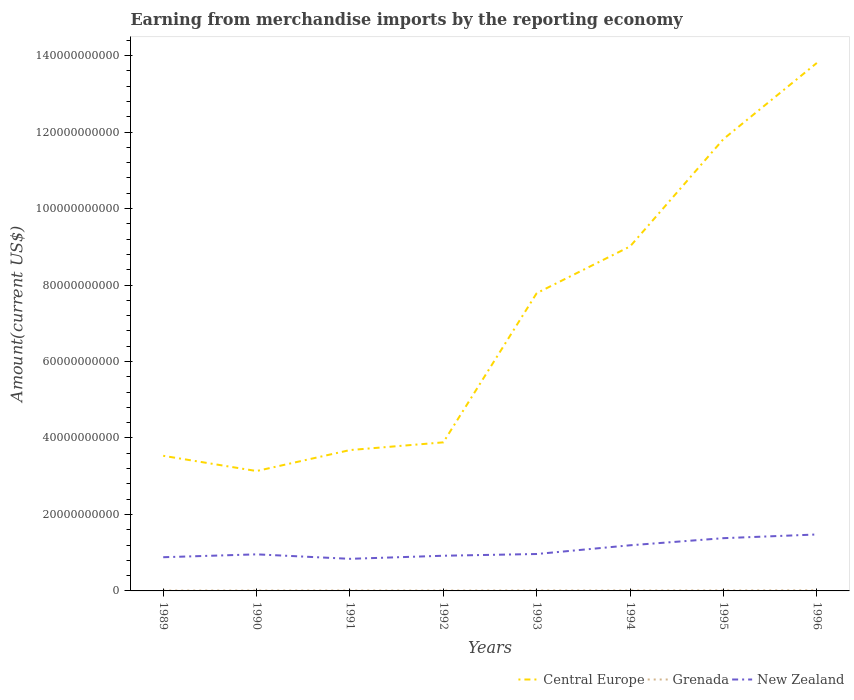Is the number of lines equal to the number of legend labels?
Keep it short and to the point. Yes. Across all years, what is the maximum amount earned from merchandise imports in New Zealand?
Give a very brief answer. 8.39e+09. What is the total amount earned from merchandise imports in New Zealand in the graph?
Keep it short and to the point. -5.95e+09. What is the difference between the highest and the second highest amount earned from merchandise imports in Grenada?
Ensure brevity in your answer.  5.36e+07. What is the difference between the highest and the lowest amount earned from merchandise imports in Grenada?
Your answer should be very brief. 3. How many years are there in the graph?
Offer a very short reply. 8. Are the values on the major ticks of Y-axis written in scientific E-notation?
Your answer should be very brief. No. Where does the legend appear in the graph?
Your answer should be compact. Bottom right. How are the legend labels stacked?
Your answer should be very brief. Horizontal. What is the title of the graph?
Give a very brief answer. Earning from merchandise imports by the reporting economy. What is the label or title of the Y-axis?
Provide a succinct answer. Amount(current US$). What is the Amount(current US$) of Central Europe in 1989?
Offer a very short reply. 3.53e+1. What is the Amount(current US$) in Grenada in 1989?
Provide a short and direct response. 1.01e+08. What is the Amount(current US$) of New Zealand in 1989?
Your answer should be compact. 8.81e+09. What is the Amount(current US$) in Central Europe in 1990?
Give a very brief answer. 3.14e+1. What is the Amount(current US$) in Grenada in 1990?
Provide a short and direct response. 1.09e+08. What is the Amount(current US$) of New Zealand in 1990?
Make the answer very short. 9.57e+09. What is the Amount(current US$) in Central Europe in 1991?
Make the answer very short. 3.68e+1. What is the Amount(current US$) of Grenada in 1991?
Your answer should be compact. 1.17e+08. What is the Amount(current US$) of New Zealand in 1991?
Provide a succinct answer. 8.39e+09. What is the Amount(current US$) of Central Europe in 1992?
Offer a terse response. 3.89e+1. What is the Amount(current US$) of Grenada in 1992?
Keep it short and to the point. 1.02e+08. What is the Amount(current US$) of New Zealand in 1992?
Make the answer very short. 9.20e+09. What is the Amount(current US$) in Central Europe in 1993?
Your response must be concise. 7.79e+1. What is the Amount(current US$) of Grenada in 1993?
Provide a succinct answer. 1.27e+08. What is the Amount(current US$) in New Zealand in 1993?
Provide a succinct answer. 9.66e+09. What is the Amount(current US$) of Central Europe in 1994?
Your answer should be very brief. 9.01e+1. What is the Amount(current US$) in Grenada in 1994?
Your response must be concise. 1.20e+08. What is the Amount(current US$) in New Zealand in 1994?
Your answer should be compact. 1.19e+1. What is the Amount(current US$) of Central Europe in 1995?
Provide a short and direct response. 1.18e+11. What is the Amount(current US$) in Grenada in 1995?
Ensure brevity in your answer.  1.30e+08. What is the Amount(current US$) of New Zealand in 1995?
Make the answer very short. 1.38e+1. What is the Amount(current US$) of Central Europe in 1996?
Your answer should be very brief. 1.38e+11. What is the Amount(current US$) in Grenada in 1996?
Offer a very short reply. 1.54e+08. What is the Amount(current US$) of New Zealand in 1996?
Your answer should be very brief. 1.48e+1. Across all years, what is the maximum Amount(current US$) in Central Europe?
Provide a short and direct response. 1.38e+11. Across all years, what is the maximum Amount(current US$) in Grenada?
Your response must be concise. 1.54e+08. Across all years, what is the maximum Amount(current US$) of New Zealand?
Ensure brevity in your answer.  1.48e+1. Across all years, what is the minimum Amount(current US$) in Central Europe?
Make the answer very short. 3.14e+1. Across all years, what is the minimum Amount(current US$) in Grenada?
Keep it short and to the point. 1.01e+08. Across all years, what is the minimum Amount(current US$) in New Zealand?
Ensure brevity in your answer.  8.39e+09. What is the total Amount(current US$) in Central Europe in the graph?
Keep it short and to the point. 5.67e+11. What is the total Amount(current US$) in Grenada in the graph?
Provide a succinct answer. 9.60e+08. What is the total Amount(current US$) of New Zealand in the graph?
Your answer should be compact. 8.61e+1. What is the difference between the Amount(current US$) of Central Europe in 1989 and that in 1990?
Ensure brevity in your answer.  3.99e+09. What is the difference between the Amount(current US$) of Grenada in 1989 and that in 1990?
Provide a short and direct response. -8.09e+06. What is the difference between the Amount(current US$) in New Zealand in 1989 and that in 1990?
Provide a short and direct response. -7.53e+08. What is the difference between the Amount(current US$) in Central Europe in 1989 and that in 1991?
Keep it short and to the point. -1.50e+09. What is the difference between the Amount(current US$) of Grenada in 1989 and that in 1991?
Your response must be concise. -1.64e+07. What is the difference between the Amount(current US$) of New Zealand in 1989 and that in 1991?
Make the answer very short. 4.20e+08. What is the difference between the Amount(current US$) in Central Europe in 1989 and that in 1992?
Make the answer very short. -3.52e+09. What is the difference between the Amount(current US$) of Grenada in 1989 and that in 1992?
Keep it short and to the point. -1.53e+06. What is the difference between the Amount(current US$) of New Zealand in 1989 and that in 1992?
Make the answer very short. -3.88e+08. What is the difference between the Amount(current US$) of Central Europe in 1989 and that in 1993?
Give a very brief answer. -4.25e+1. What is the difference between the Amount(current US$) in Grenada in 1989 and that in 1993?
Ensure brevity in your answer.  -2.57e+07. What is the difference between the Amount(current US$) of New Zealand in 1989 and that in 1993?
Give a very brief answer. -8.44e+08. What is the difference between the Amount(current US$) of Central Europe in 1989 and that in 1994?
Keep it short and to the point. -5.48e+1. What is the difference between the Amount(current US$) in Grenada in 1989 and that in 1994?
Your answer should be compact. -1.88e+07. What is the difference between the Amount(current US$) in New Zealand in 1989 and that in 1994?
Ensure brevity in your answer.  -3.12e+09. What is the difference between the Amount(current US$) of Central Europe in 1989 and that in 1995?
Provide a short and direct response. -8.28e+1. What is the difference between the Amount(current US$) of Grenada in 1989 and that in 1995?
Give a very brief answer. -2.92e+07. What is the difference between the Amount(current US$) in New Zealand in 1989 and that in 1995?
Keep it short and to the point. -4.98e+09. What is the difference between the Amount(current US$) in Central Europe in 1989 and that in 1996?
Ensure brevity in your answer.  -1.03e+11. What is the difference between the Amount(current US$) in Grenada in 1989 and that in 1996?
Your answer should be very brief. -5.36e+07. What is the difference between the Amount(current US$) in New Zealand in 1989 and that in 1996?
Your response must be concise. -5.95e+09. What is the difference between the Amount(current US$) in Central Europe in 1990 and that in 1991?
Ensure brevity in your answer.  -5.49e+09. What is the difference between the Amount(current US$) of Grenada in 1990 and that in 1991?
Ensure brevity in your answer.  -8.32e+06. What is the difference between the Amount(current US$) of New Zealand in 1990 and that in 1991?
Provide a succinct answer. 1.17e+09. What is the difference between the Amount(current US$) in Central Europe in 1990 and that in 1992?
Ensure brevity in your answer.  -7.50e+09. What is the difference between the Amount(current US$) of Grenada in 1990 and that in 1992?
Offer a very short reply. 6.56e+06. What is the difference between the Amount(current US$) of New Zealand in 1990 and that in 1992?
Your answer should be very brief. 3.65e+08. What is the difference between the Amount(current US$) in Central Europe in 1990 and that in 1993?
Your response must be concise. -4.65e+1. What is the difference between the Amount(current US$) in Grenada in 1990 and that in 1993?
Offer a terse response. -1.76e+07. What is the difference between the Amount(current US$) of New Zealand in 1990 and that in 1993?
Provide a succinct answer. -9.07e+07. What is the difference between the Amount(current US$) of Central Europe in 1990 and that in 1994?
Your answer should be compact. -5.87e+1. What is the difference between the Amount(current US$) of Grenada in 1990 and that in 1994?
Your answer should be very brief. -1.07e+07. What is the difference between the Amount(current US$) in New Zealand in 1990 and that in 1994?
Ensure brevity in your answer.  -2.37e+09. What is the difference between the Amount(current US$) in Central Europe in 1990 and that in 1995?
Keep it short and to the point. -8.68e+1. What is the difference between the Amount(current US$) of Grenada in 1990 and that in 1995?
Offer a very short reply. -2.11e+07. What is the difference between the Amount(current US$) in New Zealand in 1990 and that in 1995?
Ensure brevity in your answer.  -4.23e+09. What is the difference between the Amount(current US$) of Central Europe in 1990 and that in 1996?
Make the answer very short. -1.07e+11. What is the difference between the Amount(current US$) of Grenada in 1990 and that in 1996?
Make the answer very short. -4.55e+07. What is the difference between the Amount(current US$) in New Zealand in 1990 and that in 1996?
Your answer should be compact. -5.20e+09. What is the difference between the Amount(current US$) in Central Europe in 1991 and that in 1992?
Provide a succinct answer. -2.02e+09. What is the difference between the Amount(current US$) in Grenada in 1991 and that in 1992?
Provide a short and direct response. 1.49e+07. What is the difference between the Amount(current US$) of New Zealand in 1991 and that in 1992?
Offer a very short reply. -8.08e+08. What is the difference between the Amount(current US$) in Central Europe in 1991 and that in 1993?
Your response must be concise. -4.10e+1. What is the difference between the Amount(current US$) in Grenada in 1991 and that in 1993?
Ensure brevity in your answer.  -9.29e+06. What is the difference between the Amount(current US$) of New Zealand in 1991 and that in 1993?
Your answer should be compact. -1.26e+09. What is the difference between the Amount(current US$) in Central Europe in 1991 and that in 1994?
Your answer should be compact. -5.33e+1. What is the difference between the Amount(current US$) of Grenada in 1991 and that in 1994?
Keep it short and to the point. -2.39e+06. What is the difference between the Amount(current US$) of New Zealand in 1991 and that in 1994?
Offer a terse response. -3.54e+09. What is the difference between the Amount(current US$) of Central Europe in 1991 and that in 1995?
Your answer should be very brief. -8.13e+1. What is the difference between the Amount(current US$) in Grenada in 1991 and that in 1995?
Provide a short and direct response. -1.28e+07. What is the difference between the Amount(current US$) in New Zealand in 1991 and that in 1995?
Offer a terse response. -5.40e+09. What is the difference between the Amount(current US$) of Central Europe in 1991 and that in 1996?
Provide a short and direct response. -1.01e+11. What is the difference between the Amount(current US$) of Grenada in 1991 and that in 1996?
Offer a terse response. -3.72e+07. What is the difference between the Amount(current US$) of New Zealand in 1991 and that in 1996?
Provide a succinct answer. -6.37e+09. What is the difference between the Amount(current US$) in Central Europe in 1992 and that in 1993?
Provide a succinct answer. -3.90e+1. What is the difference between the Amount(current US$) of Grenada in 1992 and that in 1993?
Offer a terse response. -2.42e+07. What is the difference between the Amount(current US$) of New Zealand in 1992 and that in 1993?
Keep it short and to the point. -4.56e+08. What is the difference between the Amount(current US$) of Central Europe in 1992 and that in 1994?
Your response must be concise. -5.12e+1. What is the difference between the Amount(current US$) in Grenada in 1992 and that in 1994?
Provide a succinct answer. -1.73e+07. What is the difference between the Amount(current US$) in New Zealand in 1992 and that in 1994?
Your response must be concise. -2.73e+09. What is the difference between the Amount(current US$) in Central Europe in 1992 and that in 1995?
Provide a short and direct response. -7.93e+1. What is the difference between the Amount(current US$) of Grenada in 1992 and that in 1995?
Offer a very short reply. -2.77e+07. What is the difference between the Amount(current US$) in New Zealand in 1992 and that in 1995?
Offer a very short reply. -4.59e+09. What is the difference between the Amount(current US$) of Central Europe in 1992 and that in 1996?
Your answer should be compact. -9.92e+1. What is the difference between the Amount(current US$) of Grenada in 1992 and that in 1996?
Your response must be concise. -5.20e+07. What is the difference between the Amount(current US$) of New Zealand in 1992 and that in 1996?
Give a very brief answer. -5.56e+09. What is the difference between the Amount(current US$) in Central Europe in 1993 and that in 1994?
Keep it short and to the point. -1.22e+1. What is the difference between the Amount(current US$) of Grenada in 1993 and that in 1994?
Offer a very short reply. 6.89e+06. What is the difference between the Amount(current US$) in New Zealand in 1993 and that in 1994?
Your answer should be very brief. -2.28e+09. What is the difference between the Amount(current US$) of Central Europe in 1993 and that in 1995?
Your answer should be very brief. -4.03e+1. What is the difference between the Amount(current US$) of Grenada in 1993 and that in 1995?
Your response must be concise. -3.49e+06. What is the difference between the Amount(current US$) in New Zealand in 1993 and that in 1995?
Make the answer very short. -4.14e+09. What is the difference between the Amount(current US$) of Central Europe in 1993 and that in 1996?
Offer a very short reply. -6.02e+1. What is the difference between the Amount(current US$) in Grenada in 1993 and that in 1996?
Offer a very short reply. -2.79e+07. What is the difference between the Amount(current US$) in New Zealand in 1993 and that in 1996?
Provide a short and direct response. -5.11e+09. What is the difference between the Amount(current US$) of Central Europe in 1994 and that in 1995?
Your response must be concise. -2.81e+1. What is the difference between the Amount(current US$) of Grenada in 1994 and that in 1995?
Provide a short and direct response. -1.04e+07. What is the difference between the Amount(current US$) in New Zealand in 1994 and that in 1995?
Keep it short and to the point. -1.86e+09. What is the difference between the Amount(current US$) in Central Europe in 1994 and that in 1996?
Provide a short and direct response. -4.80e+1. What is the difference between the Amount(current US$) in Grenada in 1994 and that in 1996?
Your answer should be very brief. -3.48e+07. What is the difference between the Amount(current US$) of New Zealand in 1994 and that in 1996?
Ensure brevity in your answer.  -2.83e+09. What is the difference between the Amount(current US$) of Central Europe in 1995 and that in 1996?
Your answer should be compact. -1.99e+1. What is the difference between the Amount(current US$) in Grenada in 1995 and that in 1996?
Give a very brief answer. -2.44e+07. What is the difference between the Amount(current US$) in New Zealand in 1995 and that in 1996?
Ensure brevity in your answer.  -9.67e+08. What is the difference between the Amount(current US$) in Central Europe in 1989 and the Amount(current US$) in Grenada in 1990?
Give a very brief answer. 3.52e+1. What is the difference between the Amount(current US$) of Central Europe in 1989 and the Amount(current US$) of New Zealand in 1990?
Your response must be concise. 2.58e+1. What is the difference between the Amount(current US$) of Grenada in 1989 and the Amount(current US$) of New Zealand in 1990?
Your response must be concise. -9.47e+09. What is the difference between the Amount(current US$) of Central Europe in 1989 and the Amount(current US$) of Grenada in 1991?
Keep it short and to the point. 3.52e+1. What is the difference between the Amount(current US$) of Central Europe in 1989 and the Amount(current US$) of New Zealand in 1991?
Provide a succinct answer. 2.69e+1. What is the difference between the Amount(current US$) in Grenada in 1989 and the Amount(current US$) in New Zealand in 1991?
Provide a short and direct response. -8.29e+09. What is the difference between the Amount(current US$) of Central Europe in 1989 and the Amount(current US$) of Grenada in 1992?
Provide a short and direct response. 3.52e+1. What is the difference between the Amount(current US$) of Central Europe in 1989 and the Amount(current US$) of New Zealand in 1992?
Your response must be concise. 2.61e+1. What is the difference between the Amount(current US$) of Grenada in 1989 and the Amount(current US$) of New Zealand in 1992?
Your answer should be compact. -9.10e+09. What is the difference between the Amount(current US$) of Central Europe in 1989 and the Amount(current US$) of Grenada in 1993?
Ensure brevity in your answer.  3.52e+1. What is the difference between the Amount(current US$) of Central Europe in 1989 and the Amount(current US$) of New Zealand in 1993?
Ensure brevity in your answer.  2.57e+1. What is the difference between the Amount(current US$) of Grenada in 1989 and the Amount(current US$) of New Zealand in 1993?
Give a very brief answer. -9.56e+09. What is the difference between the Amount(current US$) in Central Europe in 1989 and the Amount(current US$) in Grenada in 1994?
Your answer should be very brief. 3.52e+1. What is the difference between the Amount(current US$) in Central Europe in 1989 and the Amount(current US$) in New Zealand in 1994?
Provide a succinct answer. 2.34e+1. What is the difference between the Amount(current US$) in Grenada in 1989 and the Amount(current US$) in New Zealand in 1994?
Offer a very short reply. -1.18e+1. What is the difference between the Amount(current US$) of Central Europe in 1989 and the Amount(current US$) of Grenada in 1995?
Offer a very short reply. 3.52e+1. What is the difference between the Amount(current US$) in Central Europe in 1989 and the Amount(current US$) in New Zealand in 1995?
Your answer should be very brief. 2.15e+1. What is the difference between the Amount(current US$) of Grenada in 1989 and the Amount(current US$) of New Zealand in 1995?
Your response must be concise. -1.37e+1. What is the difference between the Amount(current US$) of Central Europe in 1989 and the Amount(current US$) of Grenada in 1996?
Provide a succinct answer. 3.52e+1. What is the difference between the Amount(current US$) of Central Europe in 1989 and the Amount(current US$) of New Zealand in 1996?
Give a very brief answer. 2.06e+1. What is the difference between the Amount(current US$) of Grenada in 1989 and the Amount(current US$) of New Zealand in 1996?
Keep it short and to the point. -1.47e+1. What is the difference between the Amount(current US$) in Central Europe in 1990 and the Amount(current US$) in Grenada in 1991?
Offer a terse response. 3.12e+1. What is the difference between the Amount(current US$) in Central Europe in 1990 and the Amount(current US$) in New Zealand in 1991?
Give a very brief answer. 2.30e+1. What is the difference between the Amount(current US$) of Grenada in 1990 and the Amount(current US$) of New Zealand in 1991?
Make the answer very short. -8.28e+09. What is the difference between the Amount(current US$) of Central Europe in 1990 and the Amount(current US$) of Grenada in 1992?
Make the answer very short. 3.13e+1. What is the difference between the Amount(current US$) in Central Europe in 1990 and the Amount(current US$) in New Zealand in 1992?
Your answer should be compact. 2.22e+1. What is the difference between the Amount(current US$) in Grenada in 1990 and the Amount(current US$) in New Zealand in 1992?
Provide a succinct answer. -9.09e+09. What is the difference between the Amount(current US$) of Central Europe in 1990 and the Amount(current US$) of Grenada in 1993?
Offer a very short reply. 3.12e+1. What is the difference between the Amount(current US$) in Central Europe in 1990 and the Amount(current US$) in New Zealand in 1993?
Provide a succinct answer. 2.17e+1. What is the difference between the Amount(current US$) of Grenada in 1990 and the Amount(current US$) of New Zealand in 1993?
Provide a short and direct response. -9.55e+09. What is the difference between the Amount(current US$) of Central Europe in 1990 and the Amount(current US$) of Grenada in 1994?
Offer a very short reply. 3.12e+1. What is the difference between the Amount(current US$) in Central Europe in 1990 and the Amount(current US$) in New Zealand in 1994?
Give a very brief answer. 1.94e+1. What is the difference between the Amount(current US$) of Grenada in 1990 and the Amount(current US$) of New Zealand in 1994?
Ensure brevity in your answer.  -1.18e+1. What is the difference between the Amount(current US$) of Central Europe in 1990 and the Amount(current US$) of Grenada in 1995?
Your answer should be very brief. 3.12e+1. What is the difference between the Amount(current US$) of Central Europe in 1990 and the Amount(current US$) of New Zealand in 1995?
Your response must be concise. 1.76e+1. What is the difference between the Amount(current US$) in Grenada in 1990 and the Amount(current US$) in New Zealand in 1995?
Your response must be concise. -1.37e+1. What is the difference between the Amount(current US$) of Central Europe in 1990 and the Amount(current US$) of Grenada in 1996?
Provide a short and direct response. 3.12e+1. What is the difference between the Amount(current US$) in Central Europe in 1990 and the Amount(current US$) in New Zealand in 1996?
Offer a very short reply. 1.66e+1. What is the difference between the Amount(current US$) of Grenada in 1990 and the Amount(current US$) of New Zealand in 1996?
Offer a very short reply. -1.47e+1. What is the difference between the Amount(current US$) in Central Europe in 1991 and the Amount(current US$) in Grenada in 1992?
Provide a short and direct response. 3.67e+1. What is the difference between the Amount(current US$) in Central Europe in 1991 and the Amount(current US$) in New Zealand in 1992?
Ensure brevity in your answer.  2.76e+1. What is the difference between the Amount(current US$) of Grenada in 1991 and the Amount(current US$) of New Zealand in 1992?
Offer a terse response. -9.08e+09. What is the difference between the Amount(current US$) of Central Europe in 1991 and the Amount(current US$) of Grenada in 1993?
Keep it short and to the point. 3.67e+1. What is the difference between the Amount(current US$) in Central Europe in 1991 and the Amount(current US$) in New Zealand in 1993?
Offer a very short reply. 2.72e+1. What is the difference between the Amount(current US$) in Grenada in 1991 and the Amount(current US$) in New Zealand in 1993?
Provide a short and direct response. -9.54e+09. What is the difference between the Amount(current US$) in Central Europe in 1991 and the Amount(current US$) in Grenada in 1994?
Offer a very short reply. 3.67e+1. What is the difference between the Amount(current US$) of Central Europe in 1991 and the Amount(current US$) of New Zealand in 1994?
Your answer should be compact. 2.49e+1. What is the difference between the Amount(current US$) of Grenada in 1991 and the Amount(current US$) of New Zealand in 1994?
Offer a terse response. -1.18e+1. What is the difference between the Amount(current US$) in Central Europe in 1991 and the Amount(current US$) in Grenada in 1995?
Your answer should be very brief. 3.67e+1. What is the difference between the Amount(current US$) of Central Europe in 1991 and the Amount(current US$) of New Zealand in 1995?
Your answer should be compact. 2.30e+1. What is the difference between the Amount(current US$) in Grenada in 1991 and the Amount(current US$) in New Zealand in 1995?
Ensure brevity in your answer.  -1.37e+1. What is the difference between the Amount(current US$) in Central Europe in 1991 and the Amount(current US$) in Grenada in 1996?
Your answer should be compact. 3.67e+1. What is the difference between the Amount(current US$) of Central Europe in 1991 and the Amount(current US$) of New Zealand in 1996?
Keep it short and to the point. 2.21e+1. What is the difference between the Amount(current US$) in Grenada in 1991 and the Amount(current US$) in New Zealand in 1996?
Ensure brevity in your answer.  -1.46e+1. What is the difference between the Amount(current US$) of Central Europe in 1992 and the Amount(current US$) of Grenada in 1993?
Give a very brief answer. 3.87e+1. What is the difference between the Amount(current US$) of Central Europe in 1992 and the Amount(current US$) of New Zealand in 1993?
Ensure brevity in your answer.  2.92e+1. What is the difference between the Amount(current US$) in Grenada in 1992 and the Amount(current US$) in New Zealand in 1993?
Give a very brief answer. -9.55e+09. What is the difference between the Amount(current US$) of Central Europe in 1992 and the Amount(current US$) of Grenada in 1994?
Provide a succinct answer. 3.87e+1. What is the difference between the Amount(current US$) of Central Europe in 1992 and the Amount(current US$) of New Zealand in 1994?
Make the answer very short. 2.69e+1. What is the difference between the Amount(current US$) in Grenada in 1992 and the Amount(current US$) in New Zealand in 1994?
Keep it short and to the point. -1.18e+1. What is the difference between the Amount(current US$) in Central Europe in 1992 and the Amount(current US$) in Grenada in 1995?
Offer a terse response. 3.87e+1. What is the difference between the Amount(current US$) in Central Europe in 1992 and the Amount(current US$) in New Zealand in 1995?
Give a very brief answer. 2.51e+1. What is the difference between the Amount(current US$) of Grenada in 1992 and the Amount(current US$) of New Zealand in 1995?
Keep it short and to the point. -1.37e+1. What is the difference between the Amount(current US$) of Central Europe in 1992 and the Amount(current US$) of Grenada in 1996?
Give a very brief answer. 3.87e+1. What is the difference between the Amount(current US$) in Central Europe in 1992 and the Amount(current US$) in New Zealand in 1996?
Give a very brief answer. 2.41e+1. What is the difference between the Amount(current US$) in Grenada in 1992 and the Amount(current US$) in New Zealand in 1996?
Offer a terse response. -1.47e+1. What is the difference between the Amount(current US$) in Central Europe in 1993 and the Amount(current US$) in Grenada in 1994?
Provide a short and direct response. 7.78e+1. What is the difference between the Amount(current US$) of Central Europe in 1993 and the Amount(current US$) of New Zealand in 1994?
Your answer should be compact. 6.59e+1. What is the difference between the Amount(current US$) in Grenada in 1993 and the Amount(current US$) in New Zealand in 1994?
Offer a very short reply. -1.18e+1. What is the difference between the Amount(current US$) of Central Europe in 1993 and the Amount(current US$) of Grenada in 1995?
Provide a succinct answer. 7.77e+1. What is the difference between the Amount(current US$) in Central Europe in 1993 and the Amount(current US$) in New Zealand in 1995?
Your response must be concise. 6.41e+1. What is the difference between the Amount(current US$) of Grenada in 1993 and the Amount(current US$) of New Zealand in 1995?
Offer a very short reply. -1.37e+1. What is the difference between the Amount(current US$) in Central Europe in 1993 and the Amount(current US$) in Grenada in 1996?
Your response must be concise. 7.77e+1. What is the difference between the Amount(current US$) in Central Europe in 1993 and the Amount(current US$) in New Zealand in 1996?
Give a very brief answer. 6.31e+1. What is the difference between the Amount(current US$) in Grenada in 1993 and the Amount(current US$) in New Zealand in 1996?
Give a very brief answer. -1.46e+1. What is the difference between the Amount(current US$) of Central Europe in 1994 and the Amount(current US$) of Grenada in 1995?
Offer a very short reply. 9.00e+1. What is the difference between the Amount(current US$) of Central Europe in 1994 and the Amount(current US$) of New Zealand in 1995?
Keep it short and to the point. 7.63e+1. What is the difference between the Amount(current US$) in Grenada in 1994 and the Amount(current US$) in New Zealand in 1995?
Keep it short and to the point. -1.37e+1. What is the difference between the Amount(current US$) of Central Europe in 1994 and the Amount(current US$) of Grenada in 1996?
Offer a very short reply. 8.99e+1. What is the difference between the Amount(current US$) in Central Europe in 1994 and the Amount(current US$) in New Zealand in 1996?
Give a very brief answer. 7.53e+1. What is the difference between the Amount(current US$) in Grenada in 1994 and the Amount(current US$) in New Zealand in 1996?
Ensure brevity in your answer.  -1.46e+1. What is the difference between the Amount(current US$) of Central Europe in 1995 and the Amount(current US$) of Grenada in 1996?
Offer a terse response. 1.18e+11. What is the difference between the Amount(current US$) in Central Europe in 1995 and the Amount(current US$) in New Zealand in 1996?
Your answer should be compact. 1.03e+11. What is the difference between the Amount(current US$) in Grenada in 1995 and the Amount(current US$) in New Zealand in 1996?
Your answer should be compact. -1.46e+1. What is the average Amount(current US$) in Central Europe per year?
Keep it short and to the point. 7.08e+1. What is the average Amount(current US$) in Grenada per year?
Give a very brief answer. 1.20e+08. What is the average Amount(current US$) in New Zealand per year?
Offer a very short reply. 1.08e+1. In the year 1989, what is the difference between the Amount(current US$) in Central Europe and Amount(current US$) in Grenada?
Provide a succinct answer. 3.52e+1. In the year 1989, what is the difference between the Amount(current US$) of Central Europe and Amount(current US$) of New Zealand?
Provide a short and direct response. 2.65e+1. In the year 1989, what is the difference between the Amount(current US$) in Grenada and Amount(current US$) in New Zealand?
Ensure brevity in your answer.  -8.71e+09. In the year 1990, what is the difference between the Amount(current US$) of Central Europe and Amount(current US$) of Grenada?
Offer a terse response. 3.12e+1. In the year 1990, what is the difference between the Amount(current US$) in Central Europe and Amount(current US$) in New Zealand?
Give a very brief answer. 2.18e+1. In the year 1990, what is the difference between the Amount(current US$) in Grenada and Amount(current US$) in New Zealand?
Offer a very short reply. -9.46e+09. In the year 1991, what is the difference between the Amount(current US$) of Central Europe and Amount(current US$) of Grenada?
Your answer should be very brief. 3.67e+1. In the year 1991, what is the difference between the Amount(current US$) of Central Europe and Amount(current US$) of New Zealand?
Your answer should be compact. 2.84e+1. In the year 1991, what is the difference between the Amount(current US$) in Grenada and Amount(current US$) in New Zealand?
Ensure brevity in your answer.  -8.28e+09. In the year 1992, what is the difference between the Amount(current US$) of Central Europe and Amount(current US$) of Grenada?
Give a very brief answer. 3.88e+1. In the year 1992, what is the difference between the Amount(current US$) of Central Europe and Amount(current US$) of New Zealand?
Ensure brevity in your answer.  2.97e+1. In the year 1992, what is the difference between the Amount(current US$) of Grenada and Amount(current US$) of New Zealand?
Provide a succinct answer. -9.10e+09. In the year 1993, what is the difference between the Amount(current US$) of Central Europe and Amount(current US$) of Grenada?
Offer a terse response. 7.77e+1. In the year 1993, what is the difference between the Amount(current US$) of Central Europe and Amount(current US$) of New Zealand?
Provide a succinct answer. 6.82e+1. In the year 1993, what is the difference between the Amount(current US$) in Grenada and Amount(current US$) in New Zealand?
Offer a very short reply. -9.53e+09. In the year 1994, what is the difference between the Amount(current US$) of Central Europe and Amount(current US$) of Grenada?
Your response must be concise. 9.00e+1. In the year 1994, what is the difference between the Amount(current US$) in Central Europe and Amount(current US$) in New Zealand?
Keep it short and to the point. 7.82e+1. In the year 1994, what is the difference between the Amount(current US$) of Grenada and Amount(current US$) of New Zealand?
Keep it short and to the point. -1.18e+1. In the year 1995, what is the difference between the Amount(current US$) of Central Europe and Amount(current US$) of Grenada?
Offer a very short reply. 1.18e+11. In the year 1995, what is the difference between the Amount(current US$) in Central Europe and Amount(current US$) in New Zealand?
Your response must be concise. 1.04e+11. In the year 1995, what is the difference between the Amount(current US$) of Grenada and Amount(current US$) of New Zealand?
Ensure brevity in your answer.  -1.37e+1. In the year 1996, what is the difference between the Amount(current US$) of Central Europe and Amount(current US$) of Grenada?
Keep it short and to the point. 1.38e+11. In the year 1996, what is the difference between the Amount(current US$) of Central Europe and Amount(current US$) of New Zealand?
Keep it short and to the point. 1.23e+11. In the year 1996, what is the difference between the Amount(current US$) in Grenada and Amount(current US$) in New Zealand?
Ensure brevity in your answer.  -1.46e+1. What is the ratio of the Amount(current US$) of Central Europe in 1989 to that in 1990?
Your answer should be very brief. 1.13. What is the ratio of the Amount(current US$) of Grenada in 1989 to that in 1990?
Provide a short and direct response. 0.93. What is the ratio of the Amount(current US$) of New Zealand in 1989 to that in 1990?
Provide a short and direct response. 0.92. What is the ratio of the Amount(current US$) of Central Europe in 1989 to that in 1991?
Make the answer very short. 0.96. What is the ratio of the Amount(current US$) of Grenada in 1989 to that in 1991?
Keep it short and to the point. 0.86. What is the ratio of the Amount(current US$) of Central Europe in 1989 to that in 1992?
Your answer should be very brief. 0.91. What is the ratio of the Amount(current US$) of Grenada in 1989 to that in 1992?
Make the answer very short. 0.99. What is the ratio of the Amount(current US$) in New Zealand in 1989 to that in 1992?
Your response must be concise. 0.96. What is the ratio of the Amount(current US$) in Central Europe in 1989 to that in 1993?
Offer a terse response. 0.45. What is the ratio of the Amount(current US$) in Grenada in 1989 to that in 1993?
Give a very brief answer. 0.8. What is the ratio of the Amount(current US$) in New Zealand in 1989 to that in 1993?
Provide a short and direct response. 0.91. What is the ratio of the Amount(current US$) of Central Europe in 1989 to that in 1994?
Keep it short and to the point. 0.39. What is the ratio of the Amount(current US$) in Grenada in 1989 to that in 1994?
Your response must be concise. 0.84. What is the ratio of the Amount(current US$) in New Zealand in 1989 to that in 1994?
Provide a short and direct response. 0.74. What is the ratio of the Amount(current US$) in Central Europe in 1989 to that in 1995?
Provide a short and direct response. 0.3. What is the ratio of the Amount(current US$) in Grenada in 1989 to that in 1995?
Your answer should be very brief. 0.78. What is the ratio of the Amount(current US$) of New Zealand in 1989 to that in 1995?
Ensure brevity in your answer.  0.64. What is the ratio of the Amount(current US$) of Central Europe in 1989 to that in 1996?
Offer a terse response. 0.26. What is the ratio of the Amount(current US$) in Grenada in 1989 to that in 1996?
Offer a terse response. 0.65. What is the ratio of the Amount(current US$) in New Zealand in 1989 to that in 1996?
Provide a succinct answer. 0.6. What is the ratio of the Amount(current US$) of Central Europe in 1990 to that in 1991?
Offer a very short reply. 0.85. What is the ratio of the Amount(current US$) in Grenada in 1990 to that in 1991?
Make the answer very short. 0.93. What is the ratio of the Amount(current US$) of New Zealand in 1990 to that in 1991?
Provide a succinct answer. 1.14. What is the ratio of the Amount(current US$) in Central Europe in 1990 to that in 1992?
Make the answer very short. 0.81. What is the ratio of the Amount(current US$) of Grenada in 1990 to that in 1992?
Your answer should be very brief. 1.06. What is the ratio of the Amount(current US$) in New Zealand in 1990 to that in 1992?
Your response must be concise. 1.04. What is the ratio of the Amount(current US$) of Central Europe in 1990 to that in 1993?
Your answer should be very brief. 0.4. What is the ratio of the Amount(current US$) of Grenada in 1990 to that in 1993?
Provide a succinct answer. 0.86. What is the ratio of the Amount(current US$) of New Zealand in 1990 to that in 1993?
Provide a short and direct response. 0.99. What is the ratio of the Amount(current US$) of Central Europe in 1990 to that in 1994?
Offer a terse response. 0.35. What is the ratio of the Amount(current US$) of Grenada in 1990 to that in 1994?
Ensure brevity in your answer.  0.91. What is the ratio of the Amount(current US$) of New Zealand in 1990 to that in 1994?
Make the answer very short. 0.8. What is the ratio of the Amount(current US$) of Central Europe in 1990 to that in 1995?
Your answer should be compact. 0.27. What is the ratio of the Amount(current US$) of Grenada in 1990 to that in 1995?
Provide a short and direct response. 0.84. What is the ratio of the Amount(current US$) in New Zealand in 1990 to that in 1995?
Keep it short and to the point. 0.69. What is the ratio of the Amount(current US$) of Central Europe in 1990 to that in 1996?
Make the answer very short. 0.23. What is the ratio of the Amount(current US$) of Grenada in 1990 to that in 1996?
Offer a very short reply. 0.71. What is the ratio of the Amount(current US$) in New Zealand in 1990 to that in 1996?
Provide a short and direct response. 0.65. What is the ratio of the Amount(current US$) of Central Europe in 1991 to that in 1992?
Ensure brevity in your answer.  0.95. What is the ratio of the Amount(current US$) in Grenada in 1991 to that in 1992?
Your answer should be compact. 1.15. What is the ratio of the Amount(current US$) in New Zealand in 1991 to that in 1992?
Provide a succinct answer. 0.91. What is the ratio of the Amount(current US$) in Central Europe in 1991 to that in 1993?
Offer a terse response. 0.47. What is the ratio of the Amount(current US$) in Grenada in 1991 to that in 1993?
Your answer should be very brief. 0.93. What is the ratio of the Amount(current US$) of New Zealand in 1991 to that in 1993?
Make the answer very short. 0.87. What is the ratio of the Amount(current US$) of Central Europe in 1991 to that in 1994?
Provide a succinct answer. 0.41. What is the ratio of the Amount(current US$) in Grenada in 1991 to that in 1994?
Keep it short and to the point. 0.98. What is the ratio of the Amount(current US$) of New Zealand in 1991 to that in 1994?
Provide a short and direct response. 0.7. What is the ratio of the Amount(current US$) of Central Europe in 1991 to that in 1995?
Keep it short and to the point. 0.31. What is the ratio of the Amount(current US$) of Grenada in 1991 to that in 1995?
Your response must be concise. 0.9. What is the ratio of the Amount(current US$) of New Zealand in 1991 to that in 1995?
Your answer should be very brief. 0.61. What is the ratio of the Amount(current US$) in Central Europe in 1991 to that in 1996?
Your answer should be compact. 0.27. What is the ratio of the Amount(current US$) in Grenada in 1991 to that in 1996?
Ensure brevity in your answer.  0.76. What is the ratio of the Amount(current US$) in New Zealand in 1991 to that in 1996?
Give a very brief answer. 0.57. What is the ratio of the Amount(current US$) of Central Europe in 1992 to that in 1993?
Make the answer very short. 0.5. What is the ratio of the Amount(current US$) in Grenada in 1992 to that in 1993?
Ensure brevity in your answer.  0.81. What is the ratio of the Amount(current US$) in New Zealand in 1992 to that in 1993?
Provide a short and direct response. 0.95. What is the ratio of the Amount(current US$) in Central Europe in 1992 to that in 1994?
Offer a terse response. 0.43. What is the ratio of the Amount(current US$) in Grenada in 1992 to that in 1994?
Offer a terse response. 0.86. What is the ratio of the Amount(current US$) of New Zealand in 1992 to that in 1994?
Your answer should be compact. 0.77. What is the ratio of the Amount(current US$) in Central Europe in 1992 to that in 1995?
Offer a very short reply. 0.33. What is the ratio of the Amount(current US$) in Grenada in 1992 to that in 1995?
Your response must be concise. 0.79. What is the ratio of the Amount(current US$) of New Zealand in 1992 to that in 1995?
Provide a succinct answer. 0.67. What is the ratio of the Amount(current US$) in Central Europe in 1992 to that in 1996?
Provide a succinct answer. 0.28. What is the ratio of the Amount(current US$) of Grenada in 1992 to that in 1996?
Keep it short and to the point. 0.66. What is the ratio of the Amount(current US$) in New Zealand in 1992 to that in 1996?
Provide a short and direct response. 0.62. What is the ratio of the Amount(current US$) in Central Europe in 1993 to that in 1994?
Offer a very short reply. 0.86. What is the ratio of the Amount(current US$) of Grenada in 1993 to that in 1994?
Keep it short and to the point. 1.06. What is the ratio of the Amount(current US$) of New Zealand in 1993 to that in 1994?
Make the answer very short. 0.81. What is the ratio of the Amount(current US$) in Central Europe in 1993 to that in 1995?
Your response must be concise. 0.66. What is the ratio of the Amount(current US$) in Grenada in 1993 to that in 1995?
Offer a very short reply. 0.97. What is the ratio of the Amount(current US$) in New Zealand in 1993 to that in 1995?
Provide a short and direct response. 0.7. What is the ratio of the Amount(current US$) of Central Europe in 1993 to that in 1996?
Your response must be concise. 0.56. What is the ratio of the Amount(current US$) of Grenada in 1993 to that in 1996?
Ensure brevity in your answer.  0.82. What is the ratio of the Amount(current US$) in New Zealand in 1993 to that in 1996?
Provide a succinct answer. 0.65. What is the ratio of the Amount(current US$) in Central Europe in 1994 to that in 1995?
Offer a very short reply. 0.76. What is the ratio of the Amount(current US$) of Grenada in 1994 to that in 1995?
Offer a terse response. 0.92. What is the ratio of the Amount(current US$) in New Zealand in 1994 to that in 1995?
Your answer should be compact. 0.87. What is the ratio of the Amount(current US$) in Central Europe in 1994 to that in 1996?
Ensure brevity in your answer.  0.65. What is the ratio of the Amount(current US$) in Grenada in 1994 to that in 1996?
Make the answer very short. 0.77. What is the ratio of the Amount(current US$) in New Zealand in 1994 to that in 1996?
Provide a succinct answer. 0.81. What is the ratio of the Amount(current US$) of Central Europe in 1995 to that in 1996?
Provide a short and direct response. 0.86. What is the ratio of the Amount(current US$) in Grenada in 1995 to that in 1996?
Give a very brief answer. 0.84. What is the ratio of the Amount(current US$) of New Zealand in 1995 to that in 1996?
Ensure brevity in your answer.  0.93. What is the difference between the highest and the second highest Amount(current US$) in Central Europe?
Make the answer very short. 1.99e+1. What is the difference between the highest and the second highest Amount(current US$) in Grenada?
Give a very brief answer. 2.44e+07. What is the difference between the highest and the second highest Amount(current US$) of New Zealand?
Your answer should be very brief. 9.67e+08. What is the difference between the highest and the lowest Amount(current US$) of Central Europe?
Keep it short and to the point. 1.07e+11. What is the difference between the highest and the lowest Amount(current US$) of Grenada?
Give a very brief answer. 5.36e+07. What is the difference between the highest and the lowest Amount(current US$) of New Zealand?
Your response must be concise. 6.37e+09. 